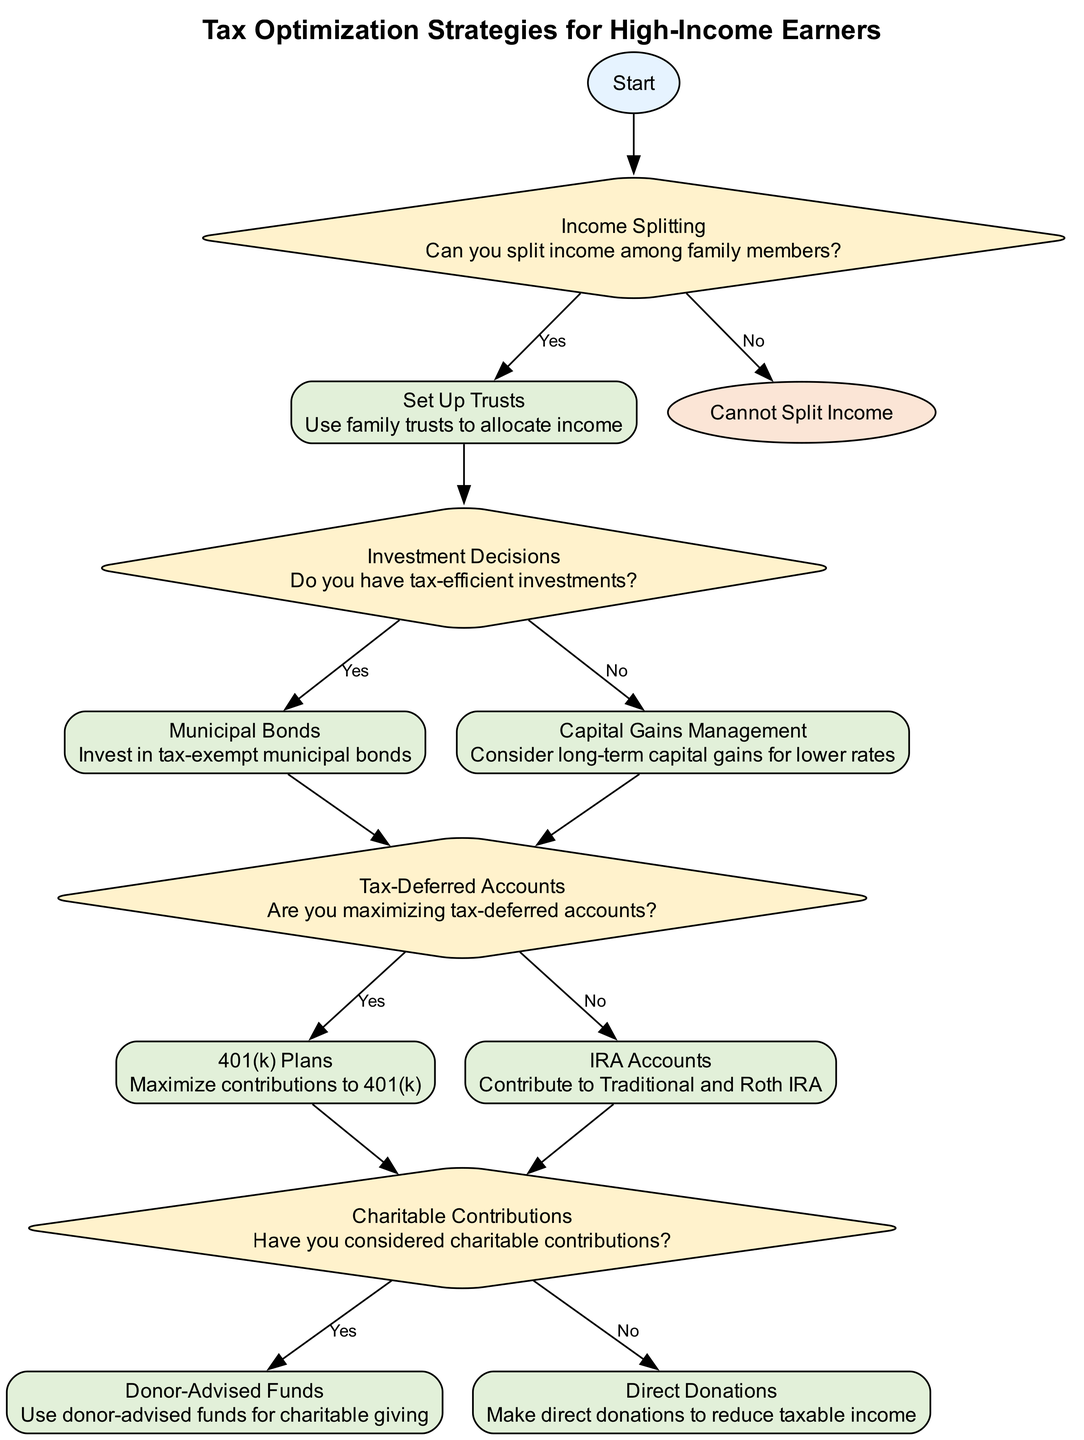What is the first decision in the diagram? The first decision is about income splitting, as indicated by the node titled "Income Splitting" which poses the question "Can you split income among family members?"
Answer: Income Splitting How many action nodes are present in the diagram? There are five action nodes: "Set Up Trusts", "Municipal Bonds", "Capital Gains Management", "401(k) Plans", "IRA Accounts", "Donor-Advised Funds", and "Direct Donations". Adding these gives a total of seven action nodes.
Answer: Seven What happens if you cannot split income? If income splitting is not possible, the flow ends at the node "Cannot Split Income", indicating no further actions or decisions from that point.
Answer: Cannot Split Income Which investment decision leads to tax-deferred accounts if you have tax-efficient investments? If you have tax-efficient investments, the path leads from "Investment Decisions" to "Municipal Bonds", then to "Tax-Deferred Accounts", which allows you to further evaluate options like 401(k) or IRA contributions.
Answer: Municipal Bonds What is an action to consider if you maximize tax-deferred accounts? When the path leads to maximizing tax-deferred accounts, the next decisions include maximizing contributions to "401(k) Plans" or "IRA Accounts", both of which are suggested actions to optimize tax benefits.
Answer: 401(k) Plans Which charitable contribution option is suggested if you consider charitable contributions? The decision node "Have you considered charitable contributions?" directs to either "Donor-Advised Funds" if you have considered them or "Direct Donations" if you have not. The category of donor-advised funds is promoted for more strategic charitable giving.
Answer: Donor-Advised Funds What condition leads to direct donations? The path leads to "Direct Donations" if the answer to the charitable contributions decision is "No", indicating a lack of consideration for other donation strategies such as donor-advised funds.
Answer: No What type of accounts do you evaluate after making investment decisions? After evaluating investment decisions, participants consider maximizing tax-deferred accounts, which typically involve contributions to accounts that defer tax liabilities.
Answer: Tax-Deferred Accounts 